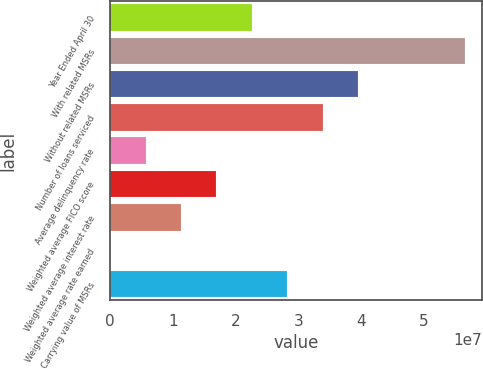<chart> <loc_0><loc_0><loc_500><loc_500><bar_chart><fcel>Year Ended April 30<fcel>With related MSRs<fcel>Without related MSRs<fcel>Number of loans serviced<fcel>Average delinquency rate<fcel>Weighted average FICO score<fcel>Weighted average interest rate<fcel>Weighted average rate earned<fcel>Carrying value of MSRs<nl><fcel>2.26086e+07<fcel>5.65216e+07<fcel>3.95651e+07<fcel>3.3913e+07<fcel>5.65216e+06<fcel>1.69565e+07<fcel>1.13043e+07<fcel>0.38<fcel>2.82608e+07<nl></chart> 